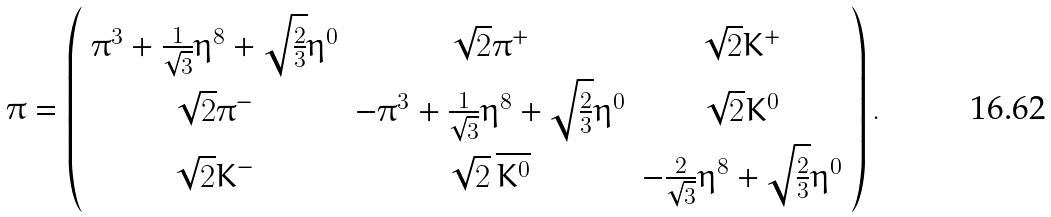<formula> <loc_0><loc_0><loc_500><loc_500>\pi = \left ( \begin{array} { c c c } \pi ^ { 3 } + \frac { 1 } { \sqrt { 3 } } \eta ^ { 8 } + \sqrt { \frac { 2 } { 3 } } \eta ^ { 0 } & \sqrt { 2 } \pi ^ { + } & \sqrt { 2 } K ^ { + } \\ \sqrt { 2 } \pi ^ { - } & - \pi ^ { 3 } + \frac { 1 } { \sqrt { 3 } } \eta ^ { 8 } + \sqrt { \frac { 2 } { 3 } } \eta ^ { 0 } & \sqrt { 2 } K ^ { 0 } \\ \sqrt { 2 } K ^ { - } & \sqrt { 2 } \, \overline { K ^ { 0 } } & - \frac { 2 } { \sqrt { 3 } } \eta ^ { 8 } + \sqrt { \frac { 2 } { 3 } } \eta ^ { 0 } \end{array} \right ) .</formula> 